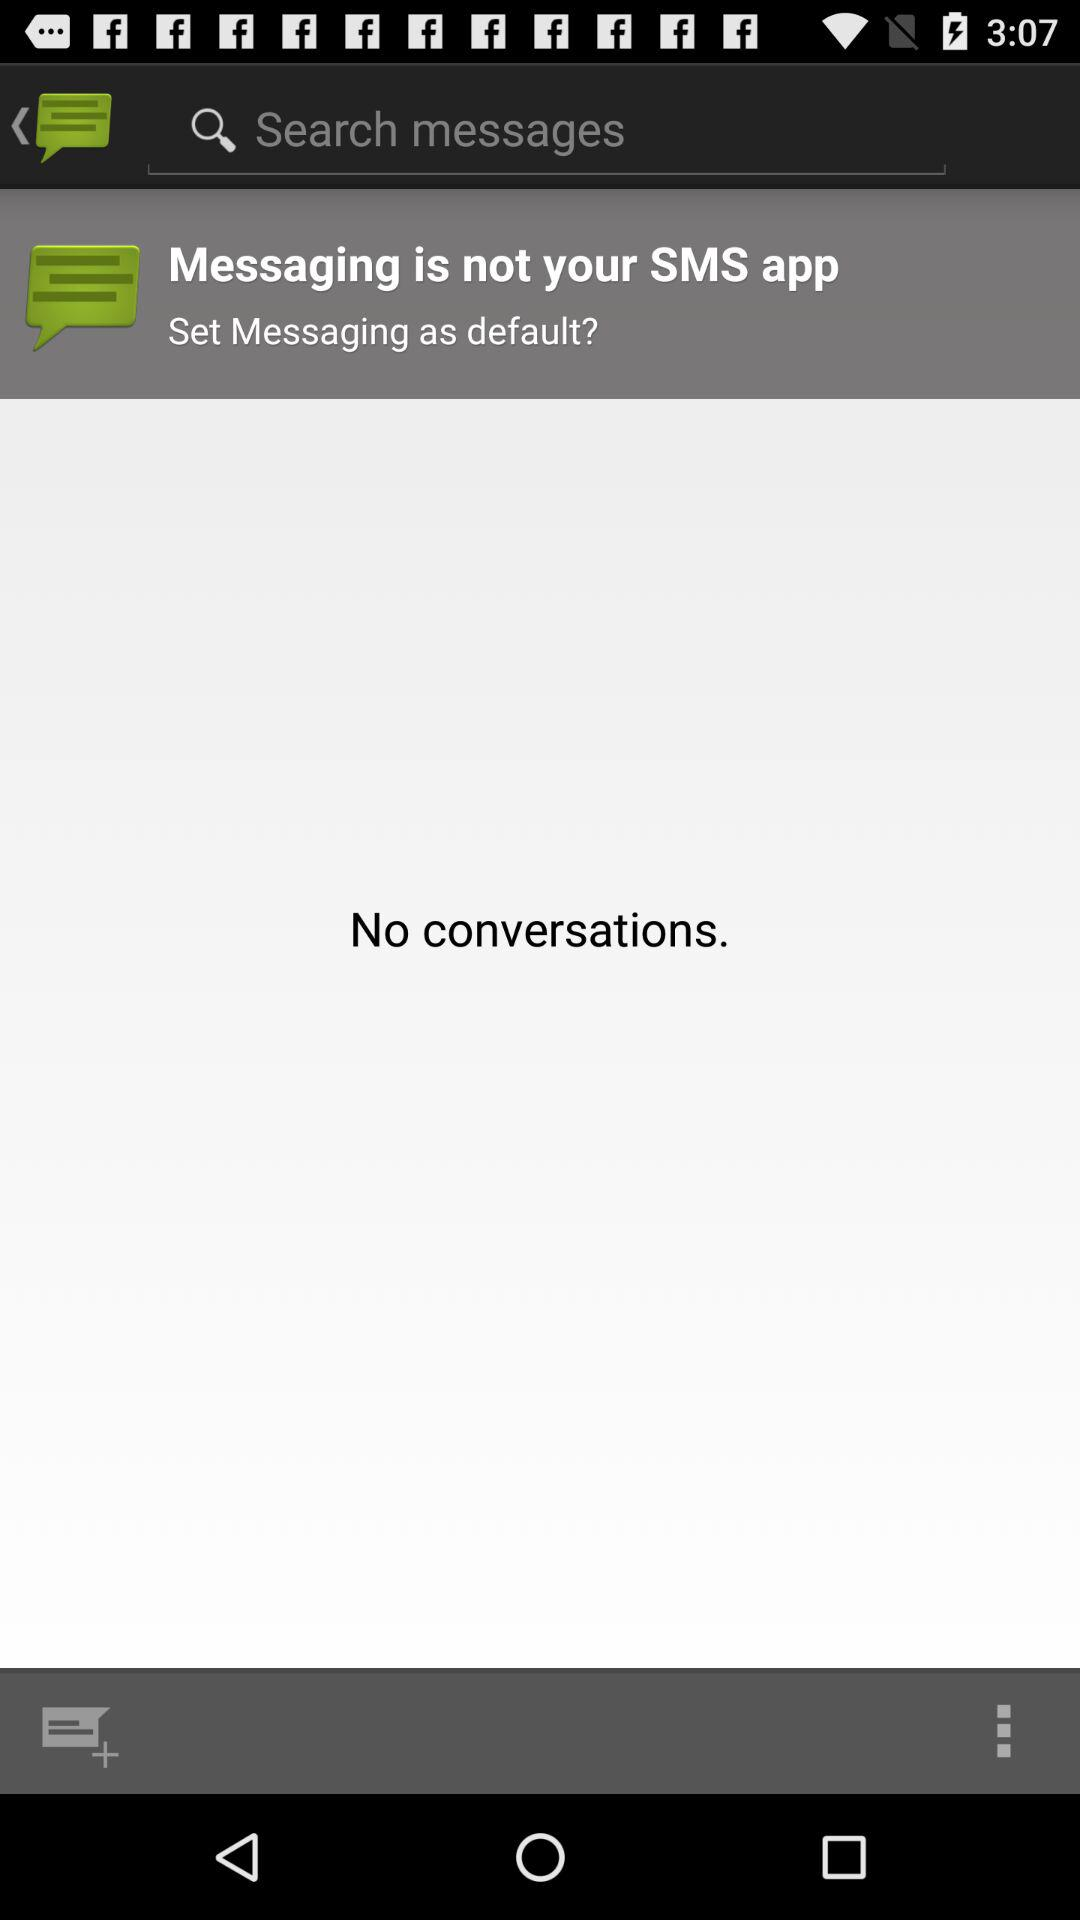Is there any conversation in the message application? There is no conversation. 